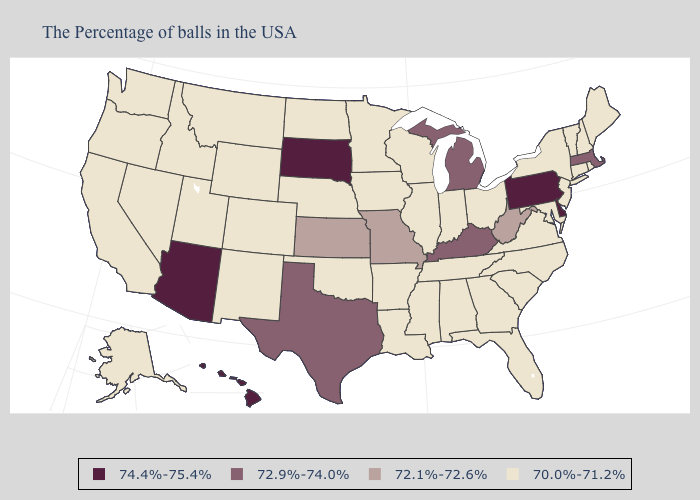What is the highest value in the West ?
Concise answer only. 74.4%-75.4%. Does the first symbol in the legend represent the smallest category?
Answer briefly. No. Does the map have missing data?
Keep it brief. No. Does Indiana have a lower value than Michigan?
Write a very short answer. Yes. Among the states that border South Dakota , which have the highest value?
Keep it brief. Minnesota, Iowa, Nebraska, North Dakota, Wyoming, Montana. What is the value of Idaho?
Quick response, please. 70.0%-71.2%. Does West Virginia have the same value as Nevada?
Answer briefly. No. What is the highest value in the South ?
Answer briefly. 74.4%-75.4%. What is the highest value in the Northeast ?
Write a very short answer. 74.4%-75.4%. What is the value of Pennsylvania?
Answer briefly. 74.4%-75.4%. Does the first symbol in the legend represent the smallest category?
Quick response, please. No. What is the highest value in the Northeast ?
Write a very short answer. 74.4%-75.4%. What is the value of Tennessee?
Keep it brief. 70.0%-71.2%. What is the highest value in the USA?
Keep it brief. 74.4%-75.4%. What is the value of California?
Answer briefly. 70.0%-71.2%. 